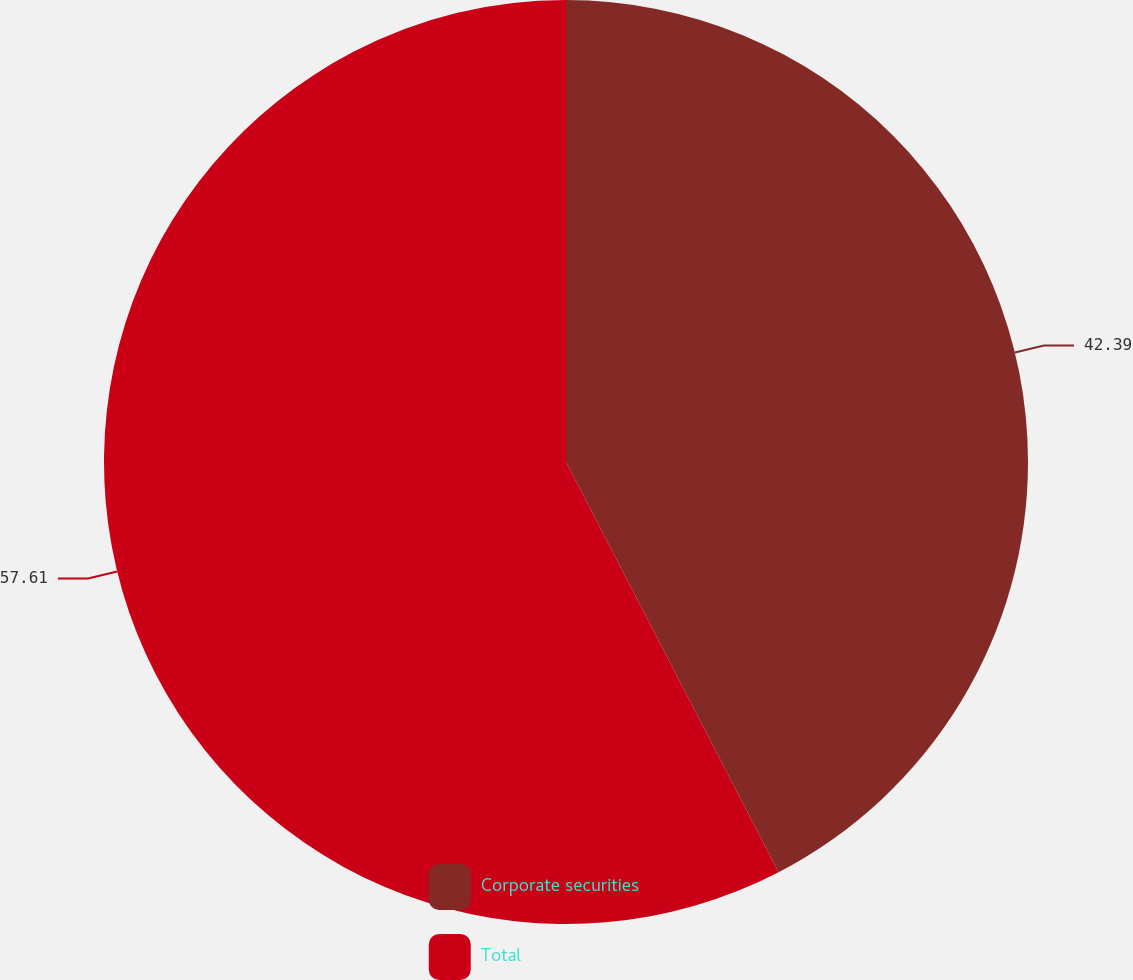Convert chart to OTSL. <chart><loc_0><loc_0><loc_500><loc_500><pie_chart><fcel>Corporate securities<fcel>Total<nl><fcel>42.39%<fcel>57.61%<nl></chart> 